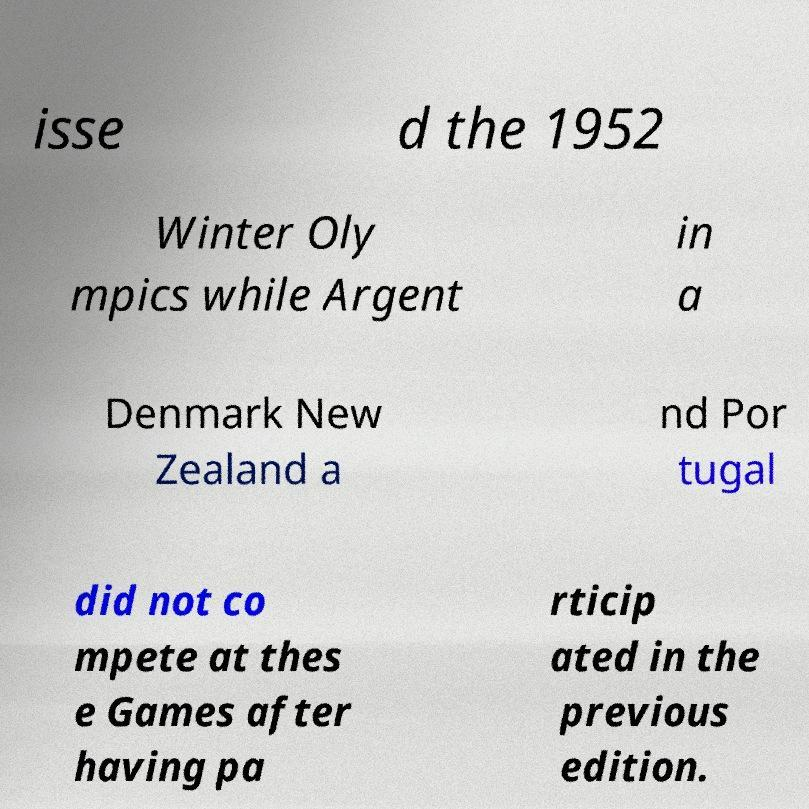What messages or text are displayed in this image? I need them in a readable, typed format. isse d the 1952 Winter Oly mpics while Argent in a Denmark New Zealand a nd Por tugal did not co mpete at thes e Games after having pa rticip ated in the previous edition. 